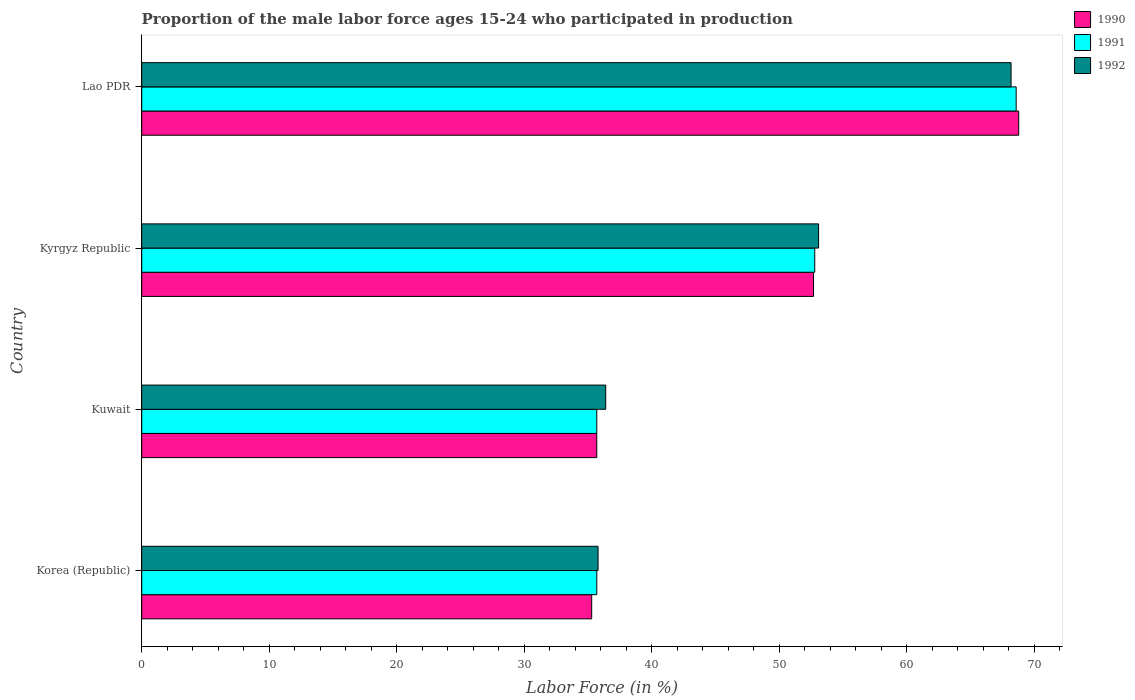How many different coloured bars are there?
Provide a succinct answer. 3. How many groups of bars are there?
Offer a terse response. 4. How many bars are there on the 2nd tick from the bottom?
Your answer should be very brief. 3. What is the label of the 2nd group of bars from the top?
Provide a succinct answer. Kyrgyz Republic. What is the proportion of the male labor force who participated in production in 1990 in Kuwait?
Your response must be concise. 35.7. Across all countries, what is the maximum proportion of the male labor force who participated in production in 1990?
Your answer should be very brief. 68.8. Across all countries, what is the minimum proportion of the male labor force who participated in production in 1992?
Provide a succinct answer. 35.8. In which country was the proportion of the male labor force who participated in production in 1990 maximum?
Provide a succinct answer. Lao PDR. What is the total proportion of the male labor force who participated in production in 1990 in the graph?
Make the answer very short. 192.5. What is the difference between the proportion of the male labor force who participated in production in 1991 in Kuwait and that in Kyrgyz Republic?
Offer a terse response. -17.1. What is the difference between the proportion of the male labor force who participated in production in 1990 in Kyrgyz Republic and the proportion of the male labor force who participated in production in 1991 in Korea (Republic)?
Offer a very short reply. 17. What is the average proportion of the male labor force who participated in production in 1991 per country?
Your response must be concise. 48.2. What is the difference between the proportion of the male labor force who participated in production in 1992 and proportion of the male labor force who participated in production in 1991 in Kyrgyz Republic?
Your response must be concise. 0.3. In how many countries, is the proportion of the male labor force who participated in production in 1992 greater than 58 %?
Your answer should be very brief. 1. What is the ratio of the proportion of the male labor force who participated in production in 1992 in Korea (Republic) to that in Kuwait?
Offer a terse response. 0.98. What is the difference between the highest and the second highest proportion of the male labor force who participated in production in 1991?
Your answer should be compact. 15.8. What is the difference between the highest and the lowest proportion of the male labor force who participated in production in 1991?
Ensure brevity in your answer.  32.9. Is it the case that in every country, the sum of the proportion of the male labor force who participated in production in 1991 and proportion of the male labor force who participated in production in 1992 is greater than the proportion of the male labor force who participated in production in 1990?
Provide a succinct answer. Yes. How many bars are there?
Provide a short and direct response. 12. Are all the bars in the graph horizontal?
Keep it short and to the point. Yes. Does the graph contain grids?
Your answer should be very brief. No. How many legend labels are there?
Ensure brevity in your answer.  3. What is the title of the graph?
Your answer should be compact. Proportion of the male labor force ages 15-24 who participated in production. What is the Labor Force (in %) of 1990 in Korea (Republic)?
Offer a terse response. 35.3. What is the Labor Force (in %) in 1991 in Korea (Republic)?
Offer a terse response. 35.7. What is the Labor Force (in %) in 1992 in Korea (Republic)?
Provide a succinct answer. 35.8. What is the Labor Force (in %) of 1990 in Kuwait?
Ensure brevity in your answer.  35.7. What is the Labor Force (in %) of 1991 in Kuwait?
Your answer should be compact. 35.7. What is the Labor Force (in %) of 1992 in Kuwait?
Make the answer very short. 36.4. What is the Labor Force (in %) in 1990 in Kyrgyz Republic?
Offer a terse response. 52.7. What is the Labor Force (in %) in 1991 in Kyrgyz Republic?
Your answer should be very brief. 52.8. What is the Labor Force (in %) of 1992 in Kyrgyz Republic?
Keep it short and to the point. 53.1. What is the Labor Force (in %) in 1990 in Lao PDR?
Your answer should be compact. 68.8. What is the Labor Force (in %) of 1991 in Lao PDR?
Your answer should be very brief. 68.6. What is the Labor Force (in %) in 1992 in Lao PDR?
Your answer should be compact. 68.2. Across all countries, what is the maximum Labor Force (in %) of 1990?
Your answer should be very brief. 68.8. Across all countries, what is the maximum Labor Force (in %) of 1991?
Provide a short and direct response. 68.6. Across all countries, what is the maximum Labor Force (in %) of 1992?
Offer a very short reply. 68.2. Across all countries, what is the minimum Labor Force (in %) in 1990?
Offer a terse response. 35.3. Across all countries, what is the minimum Labor Force (in %) in 1991?
Ensure brevity in your answer.  35.7. Across all countries, what is the minimum Labor Force (in %) in 1992?
Ensure brevity in your answer.  35.8. What is the total Labor Force (in %) of 1990 in the graph?
Offer a very short reply. 192.5. What is the total Labor Force (in %) in 1991 in the graph?
Your answer should be compact. 192.8. What is the total Labor Force (in %) in 1992 in the graph?
Ensure brevity in your answer.  193.5. What is the difference between the Labor Force (in %) of 1990 in Korea (Republic) and that in Kuwait?
Give a very brief answer. -0.4. What is the difference between the Labor Force (in %) of 1991 in Korea (Republic) and that in Kuwait?
Offer a very short reply. 0. What is the difference between the Labor Force (in %) of 1992 in Korea (Republic) and that in Kuwait?
Your response must be concise. -0.6. What is the difference between the Labor Force (in %) in 1990 in Korea (Republic) and that in Kyrgyz Republic?
Your response must be concise. -17.4. What is the difference between the Labor Force (in %) of 1991 in Korea (Republic) and that in Kyrgyz Republic?
Your answer should be very brief. -17.1. What is the difference between the Labor Force (in %) of 1992 in Korea (Republic) and that in Kyrgyz Republic?
Offer a terse response. -17.3. What is the difference between the Labor Force (in %) of 1990 in Korea (Republic) and that in Lao PDR?
Your response must be concise. -33.5. What is the difference between the Labor Force (in %) in 1991 in Korea (Republic) and that in Lao PDR?
Make the answer very short. -32.9. What is the difference between the Labor Force (in %) in 1992 in Korea (Republic) and that in Lao PDR?
Ensure brevity in your answer.  -32.4. What is the difference between the Labor Force (in %) in 1991 in Kuwait and that in Kyrgyz Republic?
Ensure brevity in your answer.  -17.1. What is the difference between the Labor Force (in %) in 1992 in Kuwait and that in Kyrgyz Republic?
Provide a short and direct response. -16.7. What is the difference between the Labor Force (in %) of 1990 in Kuwait and that in Lao PDR?
Ensure brevity in your answer.  -33.1. What is the difference between the Labor Force (in %) of 1991 in Kuwait and that in Lao PDR?
Give a very brief answer. -32.9. What is the difference between the Labor Force (in %) of 1992 in Kuwait and that in Lao PDR?
Provide a short and direct response. -31.8. What is the difference between the Labor Force (in %) in 1990 in Kyrgyz Republic and that in Lao PDR?
Your response must be concise. -16.1. What is the difference between the Labor Force (in %) of 1991 in Kyrgyz Republic and that in Lao PDR?
Your answer should be compact. -15.8. What is the difference between the Labor Force (in %) in 1992 in Kyrgyz Republic and that in Lao PDR?
Provide a short and direct response. -15.1. What is the difference between the Labor Force (in %) of 1990 in Korea (Republic) and the Labor Force (in %) of 1992 in Kuwait?
Make the answer very short. -1.1. What is the difference between the Labor Force (in %) in 1990 in Korea (Republic) and the Labor Force (in %) in 1991 in Kyrgyz Republic?
Provide a succinct answer. -17.5. What is the difference between the Labor Force (in %) of 1990 in Korea (Republic) and the Labor Force (in %) of 1992 in Kyrgyz Republic?
Your response must be concise. -17.8. What is the difference between the Labor Force (in %) in 1991 in Korea (Republic) and the Labor Force (in %) in 1992 in Kyrgyz Republic?
Your response must be concise. -17.4. What is the difference between the Labor Force (in %) of 1990 in Korea (Republic) and the Labor Force (in %) of 1991 in Lao PDR?
Your response must be concise. -33.3. What is the difference between the Labor Force (in %) of 1990 in Korea (Republic) and the Labor Force (in %) of 1992 in Lao PDR?
Provide a short and direct response. -32.9. What is the difference between the Labor Force (in %) in 1991 in Korea (Republic) and the Labor Force (in %) in 1992 in Lao PDR?
Provide a short and direct response. -32.5. What is the difference between the Labor Force (in %) in 1990 in Kuwait and the Labor Force (in %) in 1991 in Kyrgyz Republic?
Provide a short and direct response. -17.1. What is the difference between the Labor Force (in %) of 1990 in Kuwait and the Labor Force (in %) of 1992 in Kyrgyz Republic?
Ensure brevity in your answer.  -17.4. What is the difference between the Labor Force (in %) in 1991 in Kuwait and the Labor Force (in %) in 1992 in Kyrgyz Republic?
Make the answer very short. -17.4. What is the difference between the Labor Force (in %) in 1990 in Kuwait and the Labor Force (in %) in 1991 in Lao PDR?
Keep it short and to the point. -32.9. What is the difference between the Labor Force (in %) in 1990 in Kuwait and the Labor Force (in %) in 1992 in Lao PDR?
Provide a succinct answer. -32.5. What is the difference between the Labor Force (in %) in 1991 in Kuwait and the Labor Force (in %) in 1992 in Lao PDR?
Your response must be concise. -32.5. What is the difference between the Labor Force (in %) in 1990 in Kyrgyz Republic and the Labor Force (in %) in 1991 in Lao PDR?
Your response must be concise. -15.9. What is the difference between the Labor Force (in %) in 1990 in Kyrgyz Republic and the Labor Force (in %) in 1992 in Lao PDR?
Provide a short and direct response. -15.5. What is the difference between the Labor Force (in %) in 1991 in Kyrgyz Republic and the Labor Force (in %) in 1992 in Lao PDR?
Make the answer very short. -15.4. What is the average Labor Force (in %) in 1990 per country?
Keep it short and to the point. 48.12. What is the average Labor Force (in %) in 1991 per country?
Offer a terse response. 48.2. What is the average Labor Force (in %) in 1992 per country?
Your response must be concise. 48.38. What is the difference between the Labor Force (in %) of 1990 and Labor Force (in %) of 1991 in Korea (Republic)?
Ensure brevity in your answer.  -0.4. What is the difference between the Labor Force (in %) of 1990 and Labor Force (in %) of 1992 in Korea (Republic)?
Offer a very short reply. -0.5. What is the difference between the Labor Force (in %) of 1991 and Labor Force (in %) of 1992 in Korea (Republic)?
Your answer should be very brief. -0.1. What is the difference between the Labor Force (in %) of 1990 and Labor Force (in %) of 1991 in Kuwait?
Provide a succinct answer. 0. What is the difference between the Labor Force (in %) in 1990 and Labor Force (in %) in 1992 in Kuwait?
Your answer should be very brief. -0.7. What is the difference between the Labor Force (in %) in 1991 and Labor Force (in %) in 1992 in Kuwait?
Offer a very short reply. -0.7. What is the difference between the Labor Force (in %) of 1990 and Labor Force (in %) of 1991 in Kyrgyz Republic?
Ensure brevity in your answer.  -0.1. What is the difference between the Labor Force (in %) in 1990 and Labor Force (in %) in 1992 in Lao PDR?
Give a very brief answer. 0.6. What is the ratio of the Labor Force (in %) in 1992 in Korea (Republic) to that in Kuwait?
Your answer should be very brief. 0.98. What is the ratio of the Labor Force (in %) in 1990 in Korea (Republic) to that in Kyrgyz Republic?
Keep it short and to the point. 0.67. What is the ratio of the Labor Force (in %) of 1991 in Korea (Republic) to that in Kyrgyz Republic?
Offer a very short reply. 0.68. What is the ratio of the Labor Force (in %) in 1992 in Korea (Republic) to that in Kyrgyz Republic?
Your response must be concise. 0.67. What is the ratio of the Labor Force (in %) of 1990 in Korea (Republic) to that in Lao PDR?
Make the answer very short. 0.51. What is the ratio of the Labor Force (in %) in 1991 in Korea (Republic) to that in Lao PDR?
Offer a terse response. 0.52. What is the ratio of the Labor Force (in %) in 1992 in Korea (Republic) to that in Lao PDR?
Give a very brief answer. 0.52. What is the ratio of the Labor Force (in %) of 1990 in Kuwait to that in Kyrgyz Republic?
Make the answer very short. 0.68. What is the ratio of the Labor Force (in %) in 1991 in Kuwait to that in Kyrgyz Republic?
Provide a short and direct response. 0.68. What is the ratio of the Labor Force (in %) in 1992 in Kuwait to that in Kyrgyz Republic?
Your answer should be very brief. 0.69. What is the ratio of the Labor Force (in %) in 1990 in Kuwait to that in Lao PDR?
Ensure brevity in your answer.  0.52. What is the ratio of the Labor Force (in %) of 1991 in Kuwait to that in Lao PDR?
Offer a very short reply. 0.52. What is the ratio of the Labor Force (in %) of 1992 in Kuwait to that in Lao PDR?
Offer a terse response. 0.53. What is the ratio of the Labor Force (in %) of 1990 in Kyrgyz Republic to that in Lao PDR?
Give a very brief answer. 0.77. What is the ratio of the Labor Force (in %) of 1991 in Kyrgyz Republic to that in Lao PDR?
Offer a terse response. 0.77. What is the ratio of the Labor Force (in %) in 1992 in Kyrgyz Republic to that in Lao PDR?
Provide a short and direct response. 0.78. What is the difference between the highest and the second highest Labor Force (in %) of 1991?
Keep it short and to the point. 15.8. What is the difference between the highest and the lowest Labor Force (in %) in 1990?
Provide a succinct answer. 33.5. What is the difference between the highest and the lowest Labor Force (in %) in 1991?
Offer a terse response. 32.9. What is the difference between the highest and the lowest Labor Force (in %) in 1992?
Offer a terse response. 32.4. 